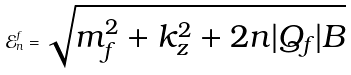<formula> <loc_0><loc_0><loc_500><loc_500>\mathcal { E } ^ { f } _ { n } = \sqrt { m _ { f } ^ { 2 } + k _ { z } ^ { 2 } + 2 n | Q _ { f } | B }</formula> 